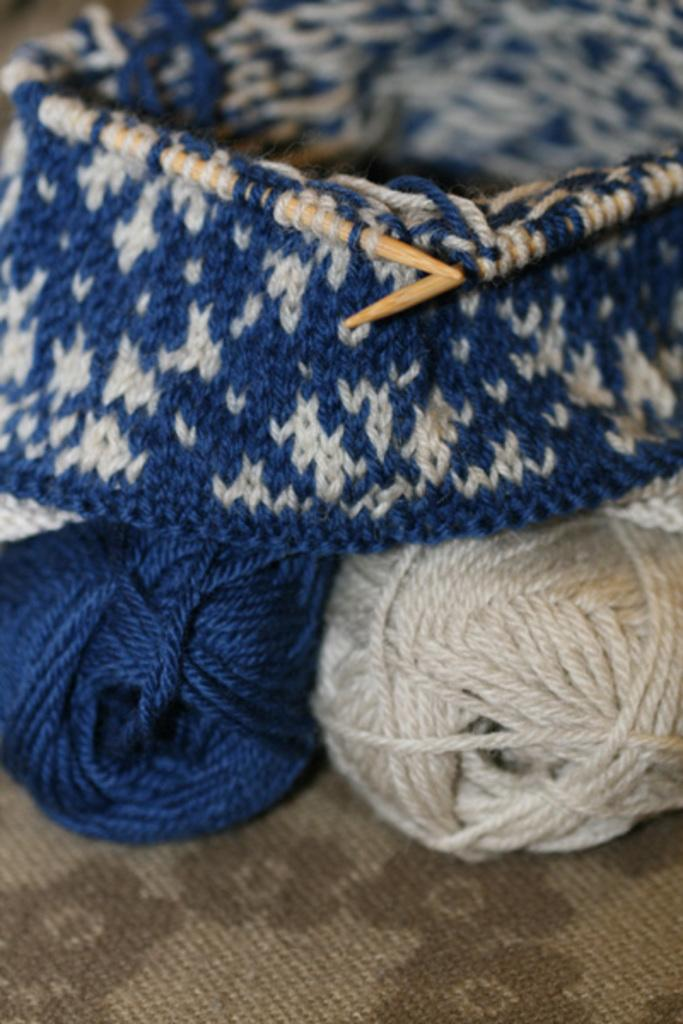What type of material is the cloth in the image made of? The cloth in the image is made of wool. What other items can be seen in the image besides the woolen cloth? There are sticks and yarns in the image. Where are the woolen cloth, sticks, and yarns located in the image? They are placed on a surface. What type of fear is depicted in the image? There is no fear depicted in the image; it features a woolen cloth, sticks, and yarns placed on a surface. What shape is the actor in the image? There is no actor present in the image. 